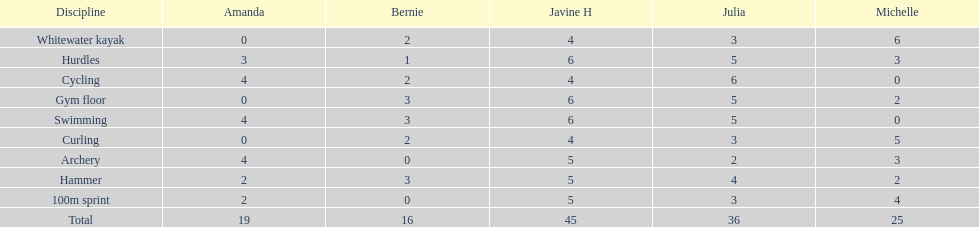What is the foremost discipline displayed on this chart? Whitewater kayak. 